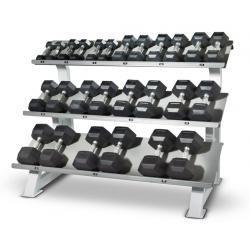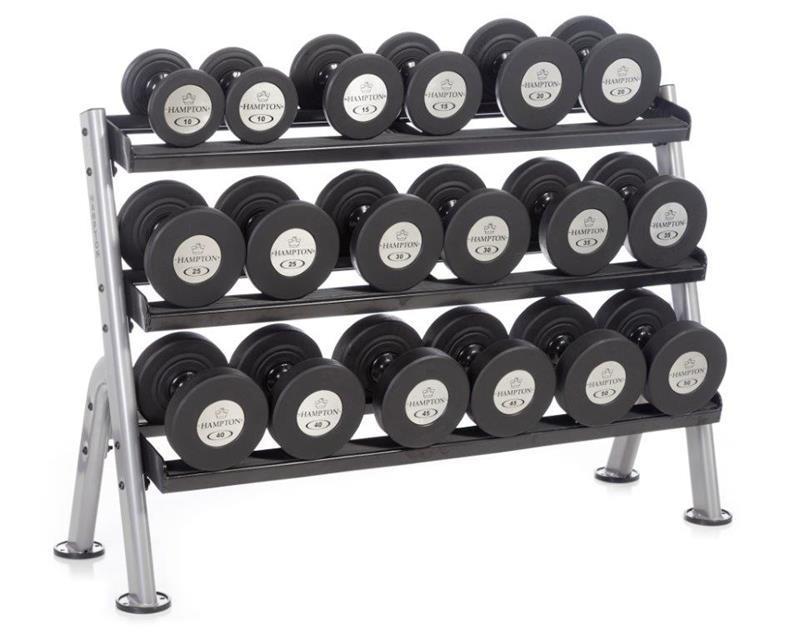The first image is the image on the left, the second image is the image on the right. Given the left and right images, does the statement "The weights sitting in the rack in the image on the left are round in shape." hold true? Answer yes or no. No. The first image is the image on the left, the second image is the image on the right. Analyze the images presented: Is the assertion "Left and right racks hold three rows of dumbbells, and dumbbells have the same end shapes in both images." valid? Answer yes or no. No. 